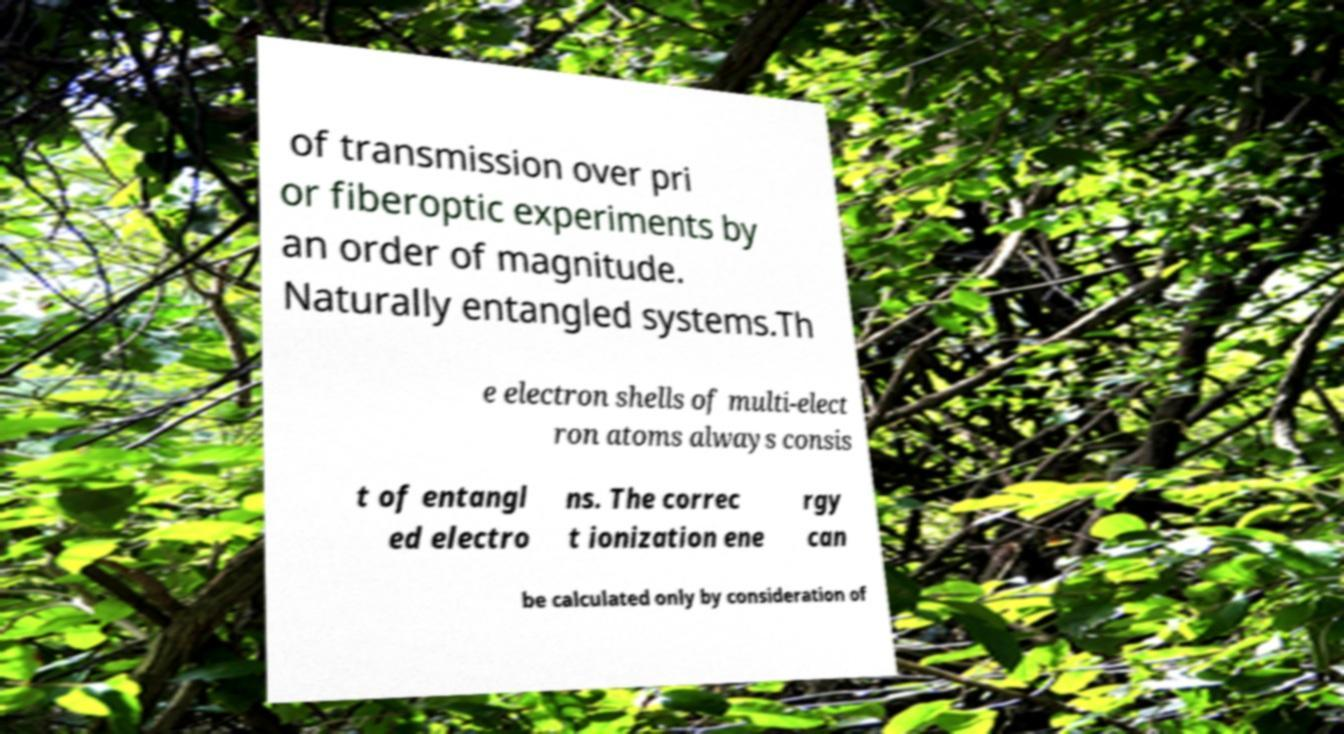For documentation purposes, I need the text within this image transcribed. Could you provide that? of transmission over pri or fiberoptic experiments by an order of magnitude. Naturally entangled systems.Th e electron shells of multi-elect ron atoms always consis t of entangl ed electro ns. The correc t ionization ene rgy can be calculated only by consideration of 